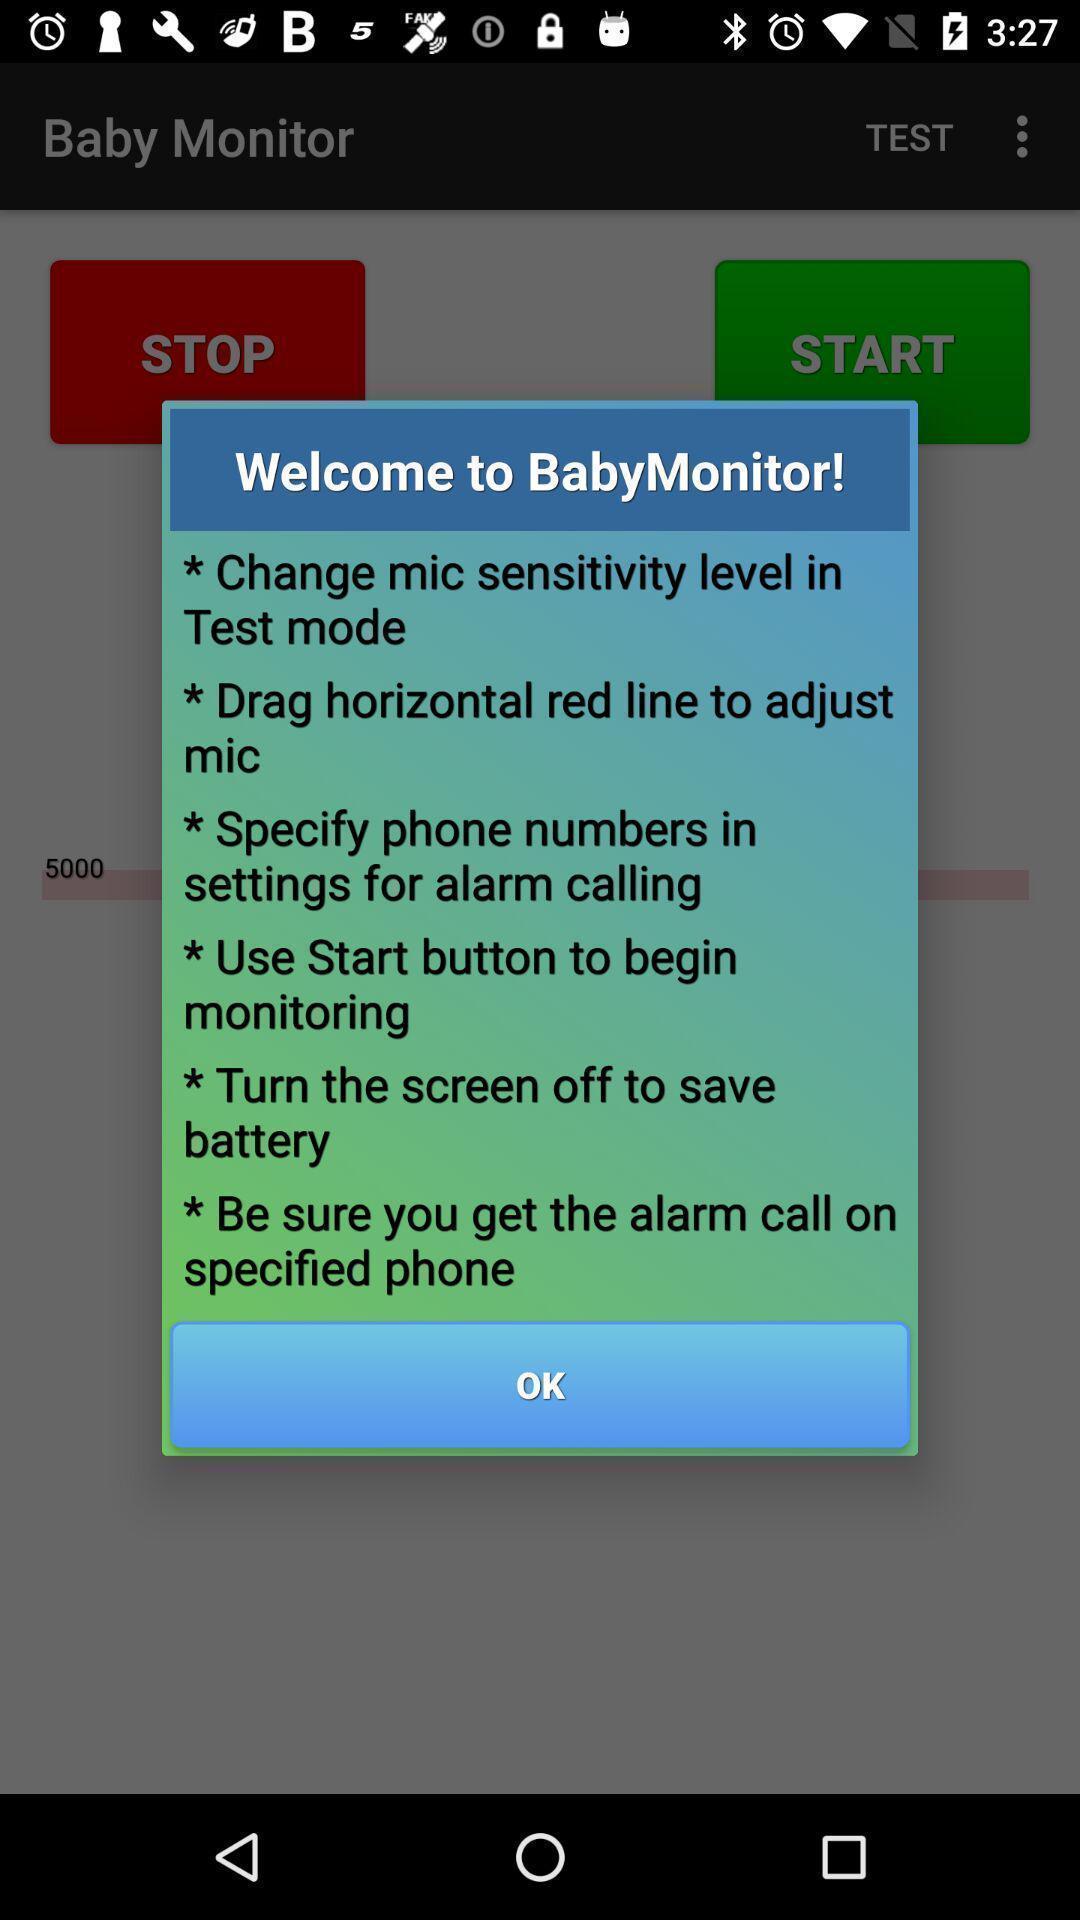Tell me about the visual elements in this screen capture. Popup displaying the welcome message. 